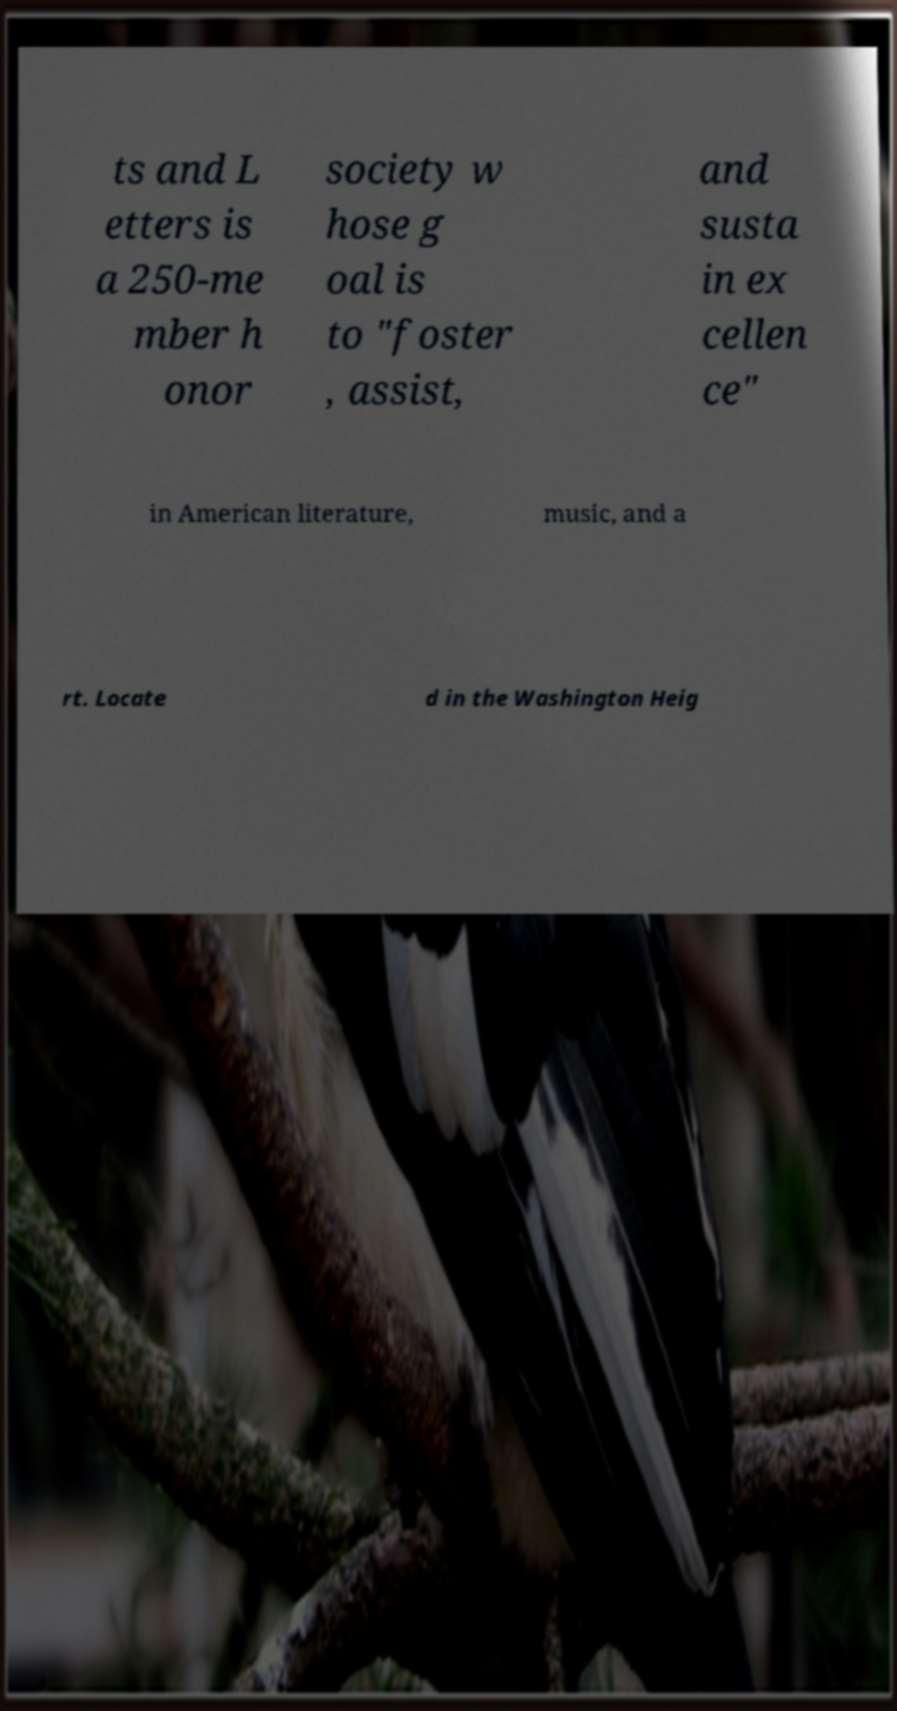Can you read and provide the text displayed in the image?This photo seems to have some interesting text. Can you extract and type it out for me? ts and L etters is a 250-me mber h onor society w hose g oal is to "foster , assist, and susta in ex cellen ce" in American literature, music, and a rt. Locate d in the Washington Heig 